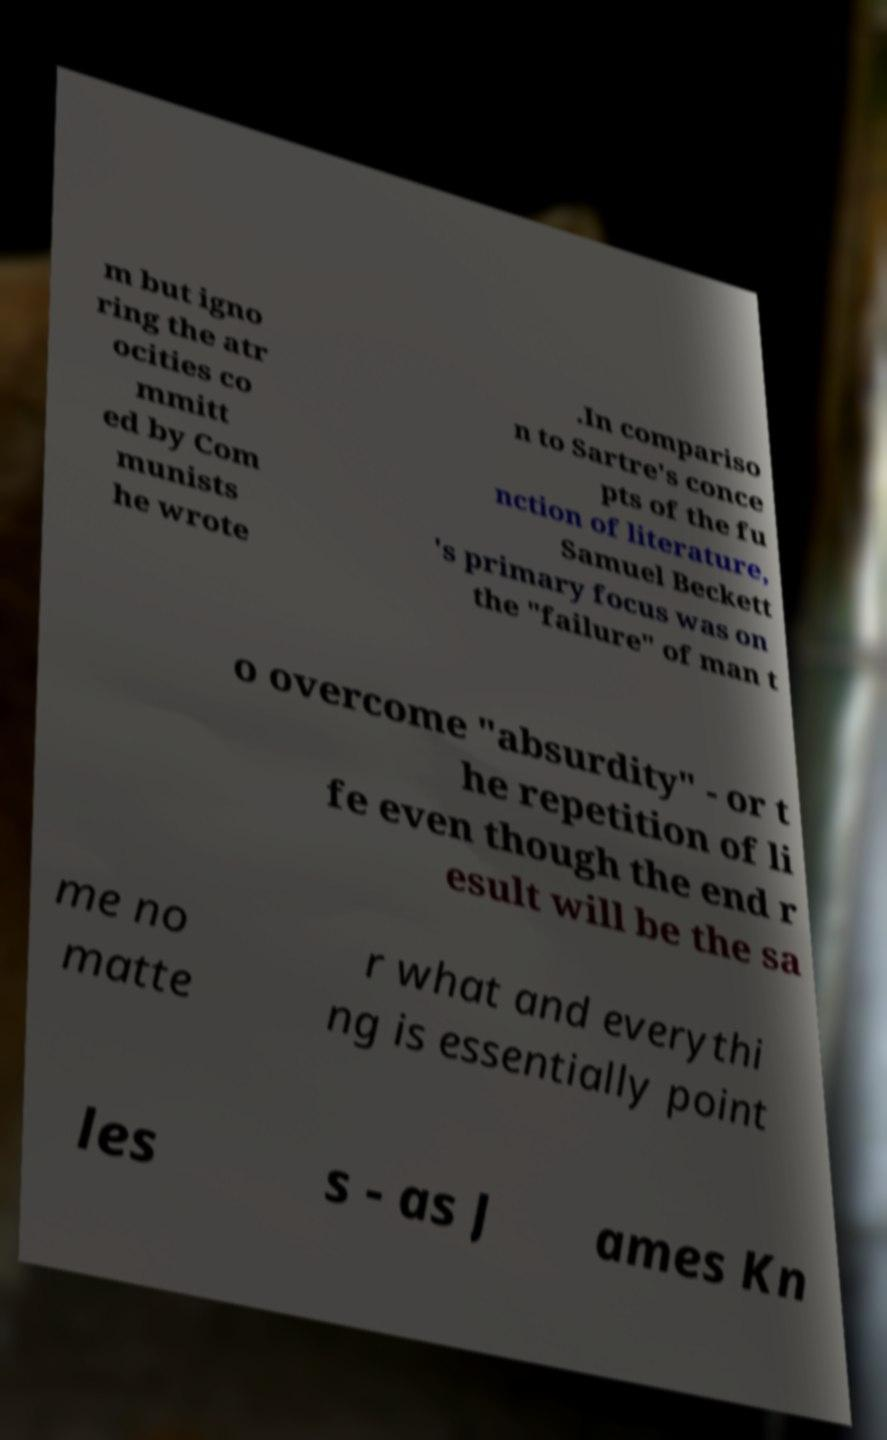What messages or text are displayed in this image? I need them in a readable, typed format. m but igno ring the atr ocities co mmitt ed by Com munists he wrote .In compariso n to Sartre's conce pts of the fu nction of literature, Samuel Beckett 's primary focus was on the "failure" of man t o overcome "absurdity" - or t he repetition of li fe even though the end r esult will be the sa me no matte r what and everythi ng is essentially point les s - as J ames Kn 